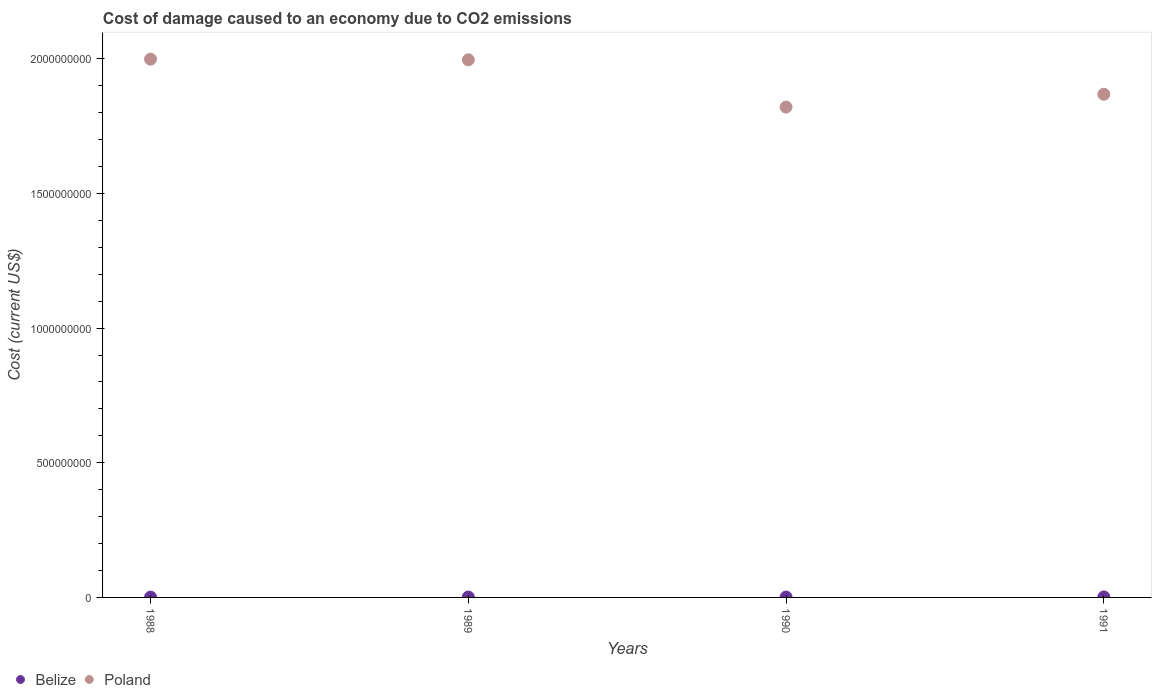How many different coloured dotlines are there?
Your answer should be very brief. 2. Is the number of dotlines equal to the number of legend labels?
Provide a short and direct response. Yes. What is the cost of damage caused due to CO2 emissisons in Belize in 1988?
Offer a very short reply. 1.12e+06. Across all years, what is the maximum cost of damage caused due to CO2 emissisons in Poland?
Your answer should be compact. 2.00e+09. Across all years, what is the minimum cost of damage caused due to CO2 emissisons in Poland?
Provide a succinct answer. 1.82e+09. In which year was the cost of damage caused due to CO2 emissisons in Belize minimum?
Ensure brevity in your answer.  1988. What is the total cost of damage caused due to CO2 emissisons in Poland in the graph?
Your answer should be compact. 7.68e+09. What is the difference between the cost of damage caused due to CO2 emissisons in Belize in 1988 and that in 1990?
Provide a succinct answer. -4.23e+05. What is the difference between the cost of damage caused due to CO2 emissisons in Poland in 1988 and the cost of damage caused due to CO2 emissisons in Belize in 1989?
Keep it short and to the point. 2.00e+09. What is the average cost of damage caused due to CO2 emissisons in Belize per year?
Offer a terse response. 1.48e+06. In the year 1991, what is the difference between the cost of damage caused due to CO2 emissisons in Belize and cost of damage caused due to CO2 emissisons in Poland?
Your answer should be compact. -1.87e+09. What is the ratio of the cost of damage caused due to CO2 emissisons in Belize in 1990 to that in 1991?
Give a very brief answer. 0.83. What is the difference between the highest and the second highest cost of damage caused due to CO2 emissisons in Poland?
Your response must be concise. 2.41e+06. What is the difference between the highest and the lowest cost of damage caused due to CO2 emissisons in Poland?
Your response must be concise. 1.78e+08. Is the sum of the cost of damage caused due to CO2 emissisons in Poland in 1988 and 1990 greater than the maximum cost of damage caused due to CO2 emissisons in Belize across all years?
Provide a succinct answer. Yes. Does the cost of damage caused due to CO2 emissisons in Poland monotonically increase over the years?
Offer a terse response. No. Is the cost of damage caused due to CO2 emissisons in Poland strictly greater than the cost of damage caused due to CO2 emissisons in Belize over the years?
Keep it short and to the point. Yes. Is the cost of damage caused due to CO2 emissisons in Belize strictly less than the cost of damage caused due to CO2 emissisons in Poland over the years?
Ensure brevity in your answer.  Yes. How many dotlines are there?
Give a very brief answer. 2. Does the graph contain any zero values?
Offer a terse response. No. Where does the legend appear in the graph?
Provide a succinct answer. Bottom left. How many legend labels are there?
Your response must be concise. 2. What is the title of the graph?
Your response must be concise. Cost of damage caused to an economy due to CO2 emissions. What is the label or title of the Y-axis?
Your response must be concise. Cost (current US$). What is the Cost (current US$) of Belize in 1988?
Ensure brevity in your answer.  1.12e+06. What is the Cost (current US$) in Poland in 1988?
Give a very brief answer. 2.00e+09. What is the Cost (current US$) in Belize in 1989?
Ensure brevity in your answer.  1.42e+06. What is the Cost (current US$) in Poland in 1989?
Provide a short and direct response. 2.00e+09. What is the Cost (current US$) of Belize in 1990?
Keep it short and to the point. 1.54e+06. What is the Cost (current US$) in Poland in 1990?
Keep it short and to the point. 1.82e+09. What is the Cost (current US$) of Belize in 1991?
Provide a succinct answer. 1.86e+06. What is the Cost (current US$) in Poland in 1991?
Your answer should be compact. 1.87e+09. Across all years, what is the maximum Cost (current US$) in Belize?
Give a very brief answer. 1.86e+06. Across all years, what is the maximum Cost (current US$) in Poland?
Make the answer very short. 2.00e+09. Across all years, what is the minimum Cost (current US$) of Belize?
Your answer should be very brief. 1.12e+06. Across all years, what is the minimum Cost (current US$) of Poland?
Provide a short and direct response. 1.82e+09. What is the total Cost (current US$) in Belize in the graph?
Your answer should be compact. 5.93e+06. What is the total Cost (current US$) of Poland in the graph?
Your answer should be very brief. 7.68e+09. What is the difference between the Cost (current US$) in Belize in 1988 and that in 1989?
Your answer should be very brief. -2.99e+05. What is the difference between the Cost (current US$) in Poland in 1988 and that in 1989?
Your answer should be very brief. 2.41e+06. What is the difference between the Cost (current US$) in Belize in 1988 and that in 1990?
Provide a short and direct response. -4.23e+05. What is the difference between the Cost (current US$) of Poland in 1988 and that in 1990?
Make the answer very short. 1.78e+08. What is the difference between the Cost (current US$) of Belize in 1988 and that in 1991?
Your response must be concise. -7.39e+05. What is the difference between the Cost (current US$) in Poland in 1988 and that in 1991?
Make the answer very short. 1.30e+08. What is the difference between the Cost (current US$) in Belize in 1989 and that in 1990?
Make the answer very short. -1.24e+05. What is the difference between the Cost (current US$) of Poland in 1989 and that in 1990?
Give a very brief answer. 1.76e+08. What is the difference between the Cost (current US$) in Belize in 1989 and that in 1991?
Give a very brief answer. -4.40e+05. What is the difference between the Cost (current US$) in Poland in 1989 and that in 1991?
Give a very brief answer. 1.28e+08. What is the difference between the Cost (current US$) in Belize in 1990 and that in 1991?
Keep it short and to the point. -3.16e+05. What is the difference between the Cost (current US$) of Poland in 1990 and that in 1991?
Give a very brief answer. -4.77e+07. What is the difference between the Cost (current US$) in Belize in 1988 and the Cost (current US$) in Poland in 1989?
Ensure brevity in your answer.  -1.99e+09. What is the difference between the Cost (current US$) of Belize in 1988 and the Cost (current US$) of Poland in 1990?
Your response must be concise. -1.82e+09. What is the difference between the Cost (current US$) in Belize in 1988 and the Cost (current US$) in Poland in 1991?
Give a very brief answer. -1.87e+09. What is the difference between the Cost (current US$) of Belize in 1989 and the Cost (current US$) of Poland in 1990?
Keep it short and to the point. -1.82e+09. What is the difference between the Cost (current US$) in Belize in 1989 and the Cost (current US$) in Poland in 1991?
Your answer should be very brief. -1.87e+09. What is the difference between the Cost (current US$) of Belize in 1990 and the Cost (current US$) of Poland in 1991?
Your answer should be compact. -1.87e+09. What is the average Cost (current US$) in Belize per year?
Provide a succinct answer. 1.48e+06. What is the average Cost (current US$) of Poland per year?
Give a very brief answer. 1.92e+09. In the year 1988, what is the difference between the Cost (current US$) of Belize and Cost (current US$) of Poland?
Keep it short and to the point. -2.00e+09. In the year 1989, what is the difference between the Cost (current US$) in Belize and Cost (current US$) in Poland?
Offer a very short reply. -1.99e+09. In the year 1990, what is the difference between the Cost (current US$) in Belize and Cost (current US$) in Poland?
Offer a very short reply. -1.82e+09. In the year 1991, what is the difference between the Cost (current US$) of Belize and Cost (current US$) of Poland?
Provide a succinct answer. -1.87e+09. What is the ratio of the Cost (current US$) in Belize in 1988 to that in 1989?
Ensure brevity in your answer.  0.79. What is the ratio of the Cost (current US$) of Poland in 1988 to that in 1989?
Offer a very short reply. 1. What is the ratio of the Cost (current US$) in Belize in 1988 to that in 1990?
Your answer should be very brief. 0.73. What is the ratio of the Cost (current US$) in Poland in 1988 to that in 1990?
Make the answer very short. 1.1. What is the ratio of the Cost (current US$) of Belize in 1988 to that in 1991?
Give a very brief answer. 0.6. What is the ratio of the Cost (current US$) in Poland in 1988 to that in 1991?
Give a very brief answer. 1.07. What is the ratio of the Cost (current US$) of Belize in 1989 to that in 1990?
Provide a short and direct response. 0.92. What is the ratio of the Cost (current US$) in Poland in 1989 to that in 1990?
Make the answer very short. 1.1. What is the ratio of the Cost (current US$) in Belize in 1989 to that in 1991?
Your answer should be very brief. 0.76. What is the ratio of the Cost (current US$) of Poland in 1989 to that in 1991?
Ensure brevity in your answer.  1.07. What is the ratio of the Cost (current US$) in Belize in 1990 to that in 1991?
Make the answer very short. 0.83. What is the ratio of the Cost (current US$) of Poland in 1990 to that in 1991?
Keep it short and to the point. 0.97. What is the difference between the highest and the second highest Cost (current US$) of Belize?
Provide a short and direct response. 3.16e+05. What is the difference between the highest and the second highest Cost (current US$) in Poland?
Your response must be concise. 2.41e+06. What is the difference between the highest and the lowest Cost (current US$) in Belize?
Your answer should be compact. 7.39e+05. What is the difference between the highest and the lowest Cost (current US$) in Poland?
Your answer should be very brief. 1.78e+08. 